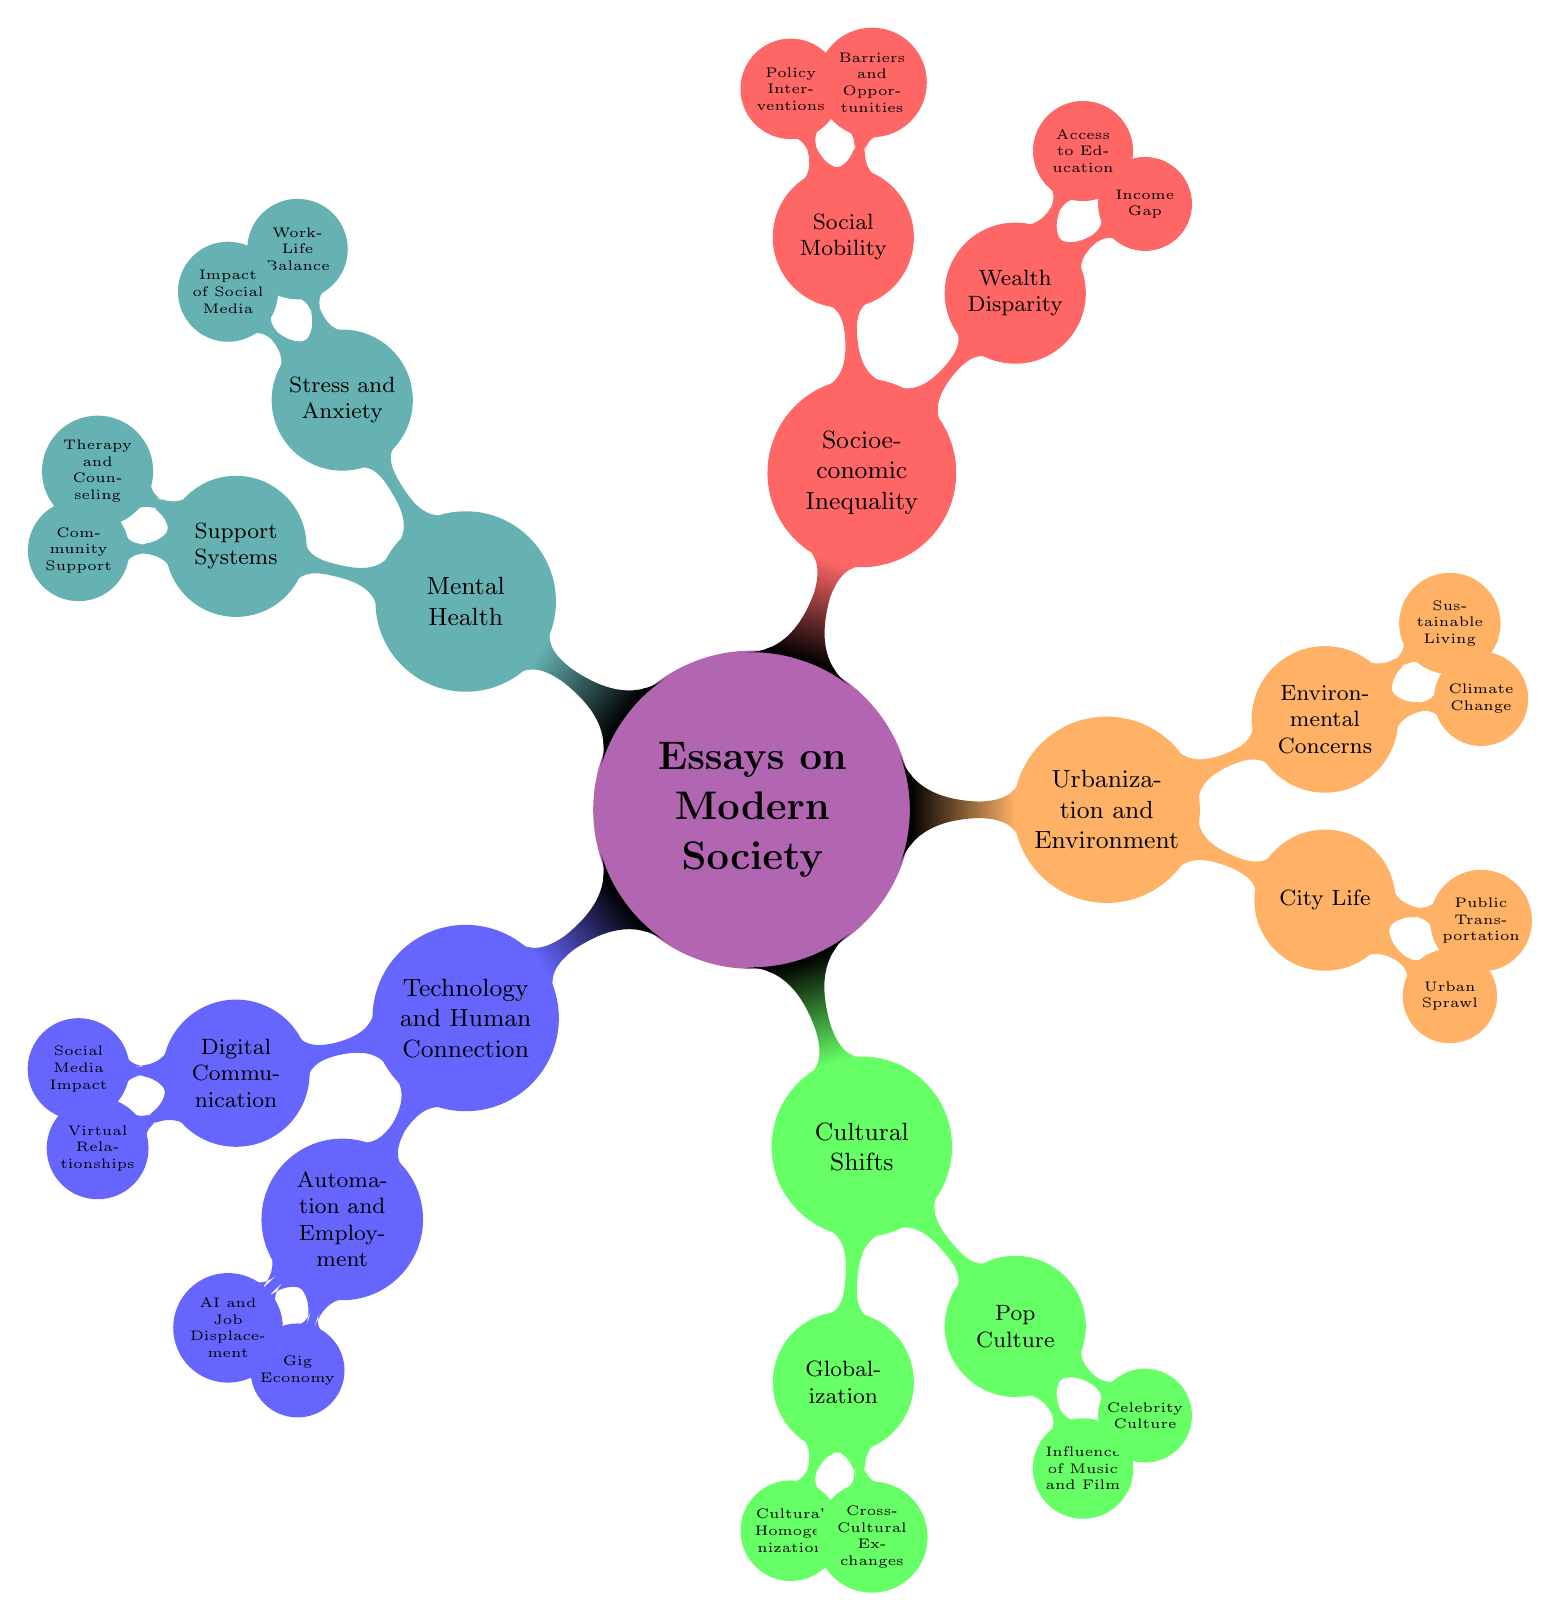What are the two main categories under "Technology and Human Connection"? The main categories under "Technology and Human Connection" are "Digital Communication" and "Automation and Employment". These categories are the first level branches stemming from the central node.
Answer: Digital Communication, Automation and Employment How many nodes are there under "Cultural Shifts"? Under "Cultural Shifts," there are two main nodes: "Globalization" and "Pop Culture". Each of those has two sub-nodes, making a total of four nodes under "Cultural Shifts" when counting all levels.
Answer: 4 What is one of the concerns listed under "Environmental Concerns"? The node "Environmental Concerns" branches out into "Climate Change" and "Sustainable Living". Each of these is a concern stemming from the central node of "Environmental Concerns".
Answer: Climate Change Which aspect of "Mental Health" is connected to "Work-Life Balance"? "Work-Life Balance" is a sub-topic under the "Stress and Anxiety" node within "Mental Health". This indicates its relationship where it is specifically related to mental health challenges.
Answer: Stress and Anxiety What is the total number of sub-nodes in the "Socioeconomic Inequality" category? "Socioeconomic Inequality" includes two main branches: "Wealth Disparity" and "Social Mobility". Each of these has two sub-nodes, so there are a total of four sub-nodes in this category.
Answer: 4 Which category includes "Urban Sprawl"? "Urban Sprawl" is a specific node under the "City Life" branch, which is part of the "Urbanization and Environment" category. Thus, it pertains to the urbanization and environment aspect of modern society.
Answer: Urbanization and Environment How many nodes are related to "Digital Communication"? The "Digital Communication" category branches into two sub-nodes: "Social Media Impact" and "Virtual Relationships", making a total of three nodes, including the parent node itself.
Answer: 3 What does "AI and Job Displacement" relate to in the diagram? "AI and Job Displacement" is a sub-node of "Automation and Employment," which is a second-level node under the "Technology and Human Connection" main category, indicating its specific relation to employment impacts caused by technology.
Answer: Automation and Employment 